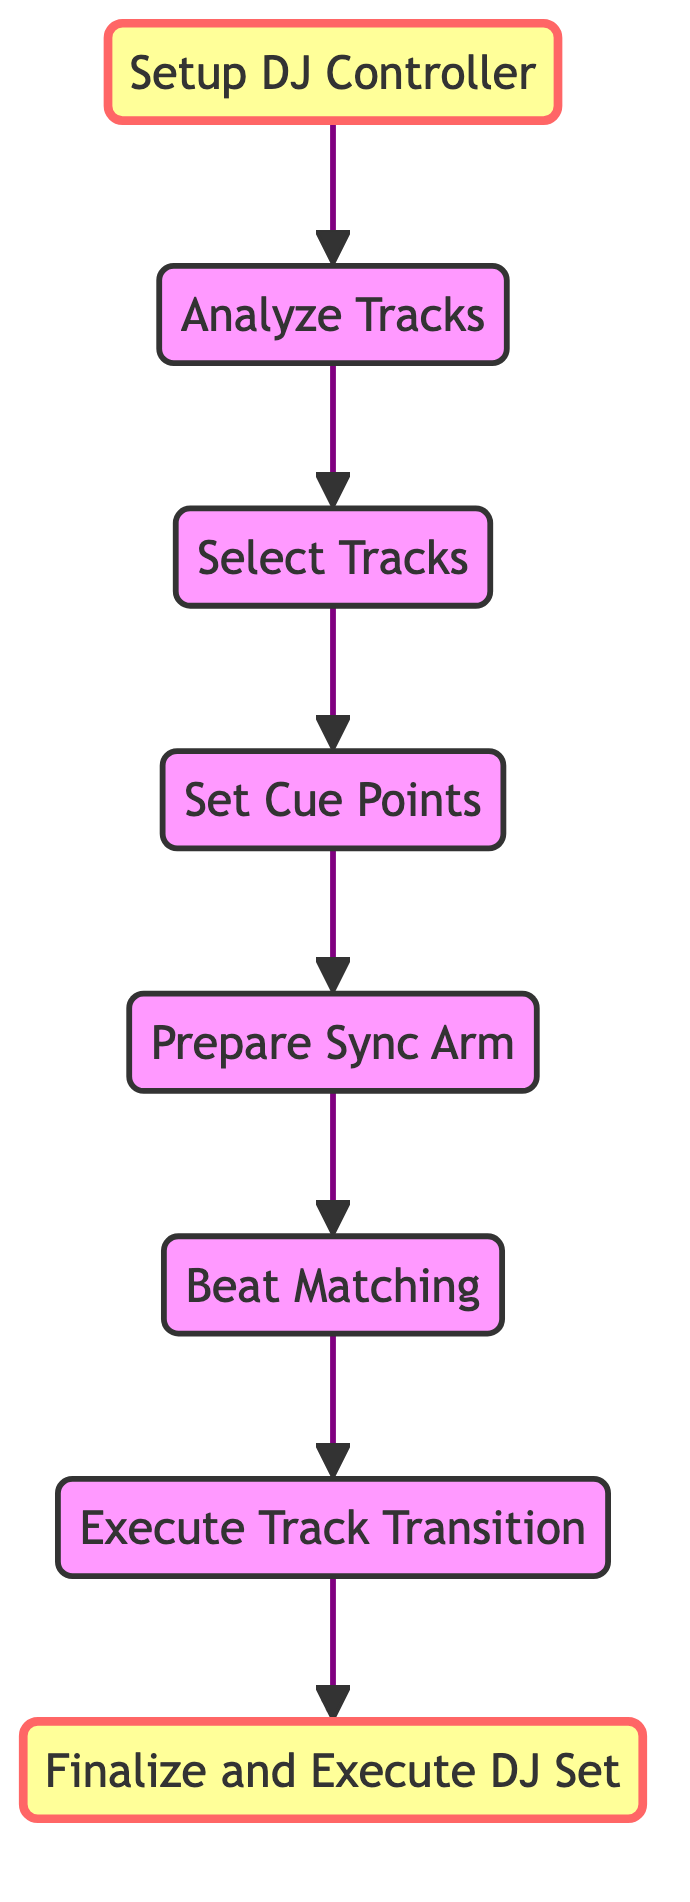What is the first step in the process? The first step shown in the diagram is "Setup DJ Controller." It is the starting point before any further actions can be taken.
Answer: Setup DJ Controller How many nodes are depicted in the diagram? The diagram contains a total of eight nodes, which represent distinct steps in the process of beat matching and executing a DJ set.
Answer: Eight What node comes after "Set Cue Points"? The node that follows "Set Cue Points" is "Prepare Sync Arm." This shows the sequence in which actions are taken during the DJ process.
Answer: Prepare Sync Arm Which two nodes have a direct connection? The nodes "Beat Matching" and "Execute Track Transition" have a direct connection, indicating that after matching beats, the DJ moves onto executing the transition between tracks.
Answer: Beat Matching and Execute Track Transition What is the final node in the flowchart? The last node at the top of the flowchart is "Finalize and Execute DJ Set," which signifies the completion of the entire process.
Answer: Finalize and Execute DJ Set Which step must be completed before beat matching can occur? Prior to "Beat Matching," one must complete "Prepare Sync Arm." This step is essential as it ensures the tracks' downbeats are aligned before matching their tempos.
Answer: Prepare Sync Arm What is the purpose of the "Analyze Tracks" step? The "Analyze Tracks" step is designed to evaluate tracks for their BPM and key, ensuring that they are compatible and can transition harmoniously into one another.
Answer: Evaluate tracks for BPM and key What sequence of actions must be taken to go from "Select Tracks" to "Finalize and Execute DJ Set"? The sequence is: after "Select Tracks," one must first complete "Set Cue Points," then "Prepare Sync Arm," followed by "Beat Matching," then move to "Execute Track Transition," which finally leads to "Finalize and Execute DJ Set." This illustrates the necessary steps to reach the final stage.
Answer: Select Tracks, Set Cue Points, Prepare Sync Arm, Beat Matching, Execute Track Transition, Finalize and Execute DJ Set 